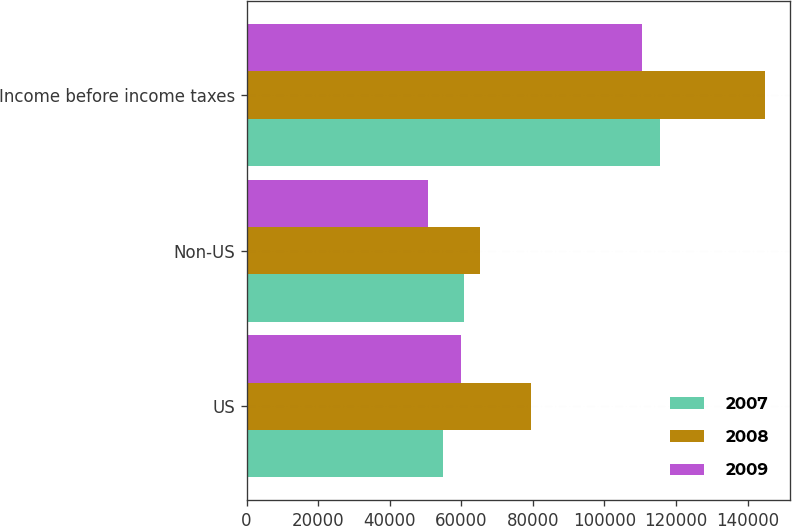Convert chart. <chart><loc_0><loc_0><loc_500><loc_500><stacked_bar_chart><ecel><fcel>US<fcel>Non-US<fcel>Income before income taxes<nl><fcel>2007<fcel>54793<fcel>60733<fcel>115526<nl><fcel>2008<fcel>79393<fcel>65348<fcel>144741<nl><fcel>2009<fcel>59884<fcel>50613<fcel>110497<nl></chart> 